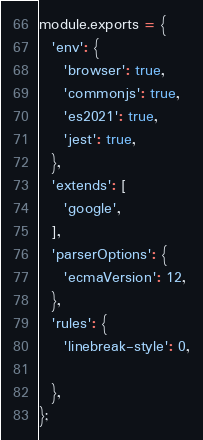<code> <loc_0><loc_0><loc_500><loc_500><_JavaScript_>module.exports = {
  'env': {
    'browser': true,
    'commonjs': true,
    'es2021': true,
    'jest': true,
  },
  'extends': [
    'google',
  ],
  'parserOptions': {
    'ecmaVersion': 12,
  },
  'rules': {
    'linebreak-style': 0,

  },
};
</code> 